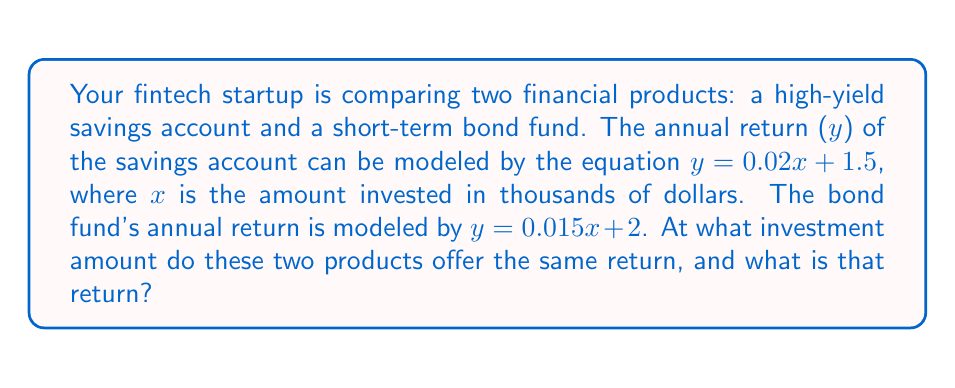Teach me how to tackle this problem. To find the intersection point of these two linear equations, we need to solve them simultaneously:

1) Set the equations equal to each other:
   $0.02x + 1.5 = 0.015x + 2$

2) Subtract 0.015x from both sides:
   $0.005x + 1.5 = 2$

3) Subtract 1.5 from both sides:
   $0.005x = 0.5$

4) Divide both sides by 0.005:
   $x = 100$

5) Now that we know the x-coordinate (investment amount), we can substitute it into either equation to find the y-coordinate (return):
   $y = 0.02(100) + 1.5 = 2 + 1.5 = 3.5$

Therefore, the intersection point is at (100, 3.5).
Answer: (100, 3.5) 